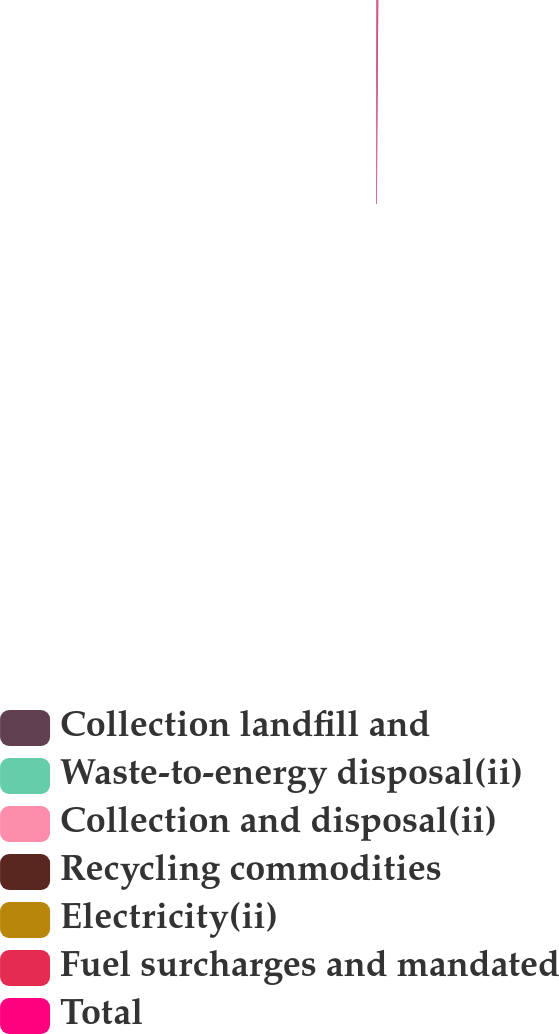<chart> <loc_0><loc_0><loc_500><loc_500><pie_chart><fcel>Collection landfill and<fcel>Waste-to-energy disposal(ii)<fcel>Collection and disposal(ii)<fcel>Recycling commodities<fcel>Electricity(ii)<fcel>Fuel surcharges and mandated<fcel>Total<nl><fcel>11.7%<fcel>4.14%<fcel>15.47%<fcel>22.27%<fcel>0.37%<fcel>7.92%<fcel>38.13%<nl></chart> 